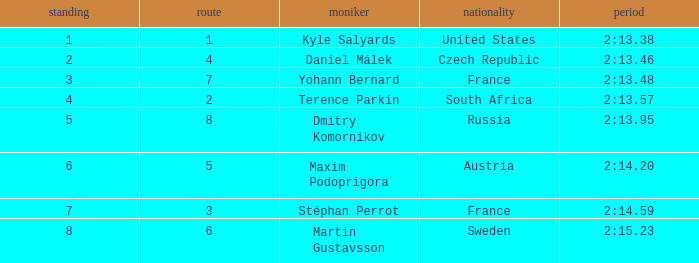What was Stéphan Perrot rank average? 7.0. 